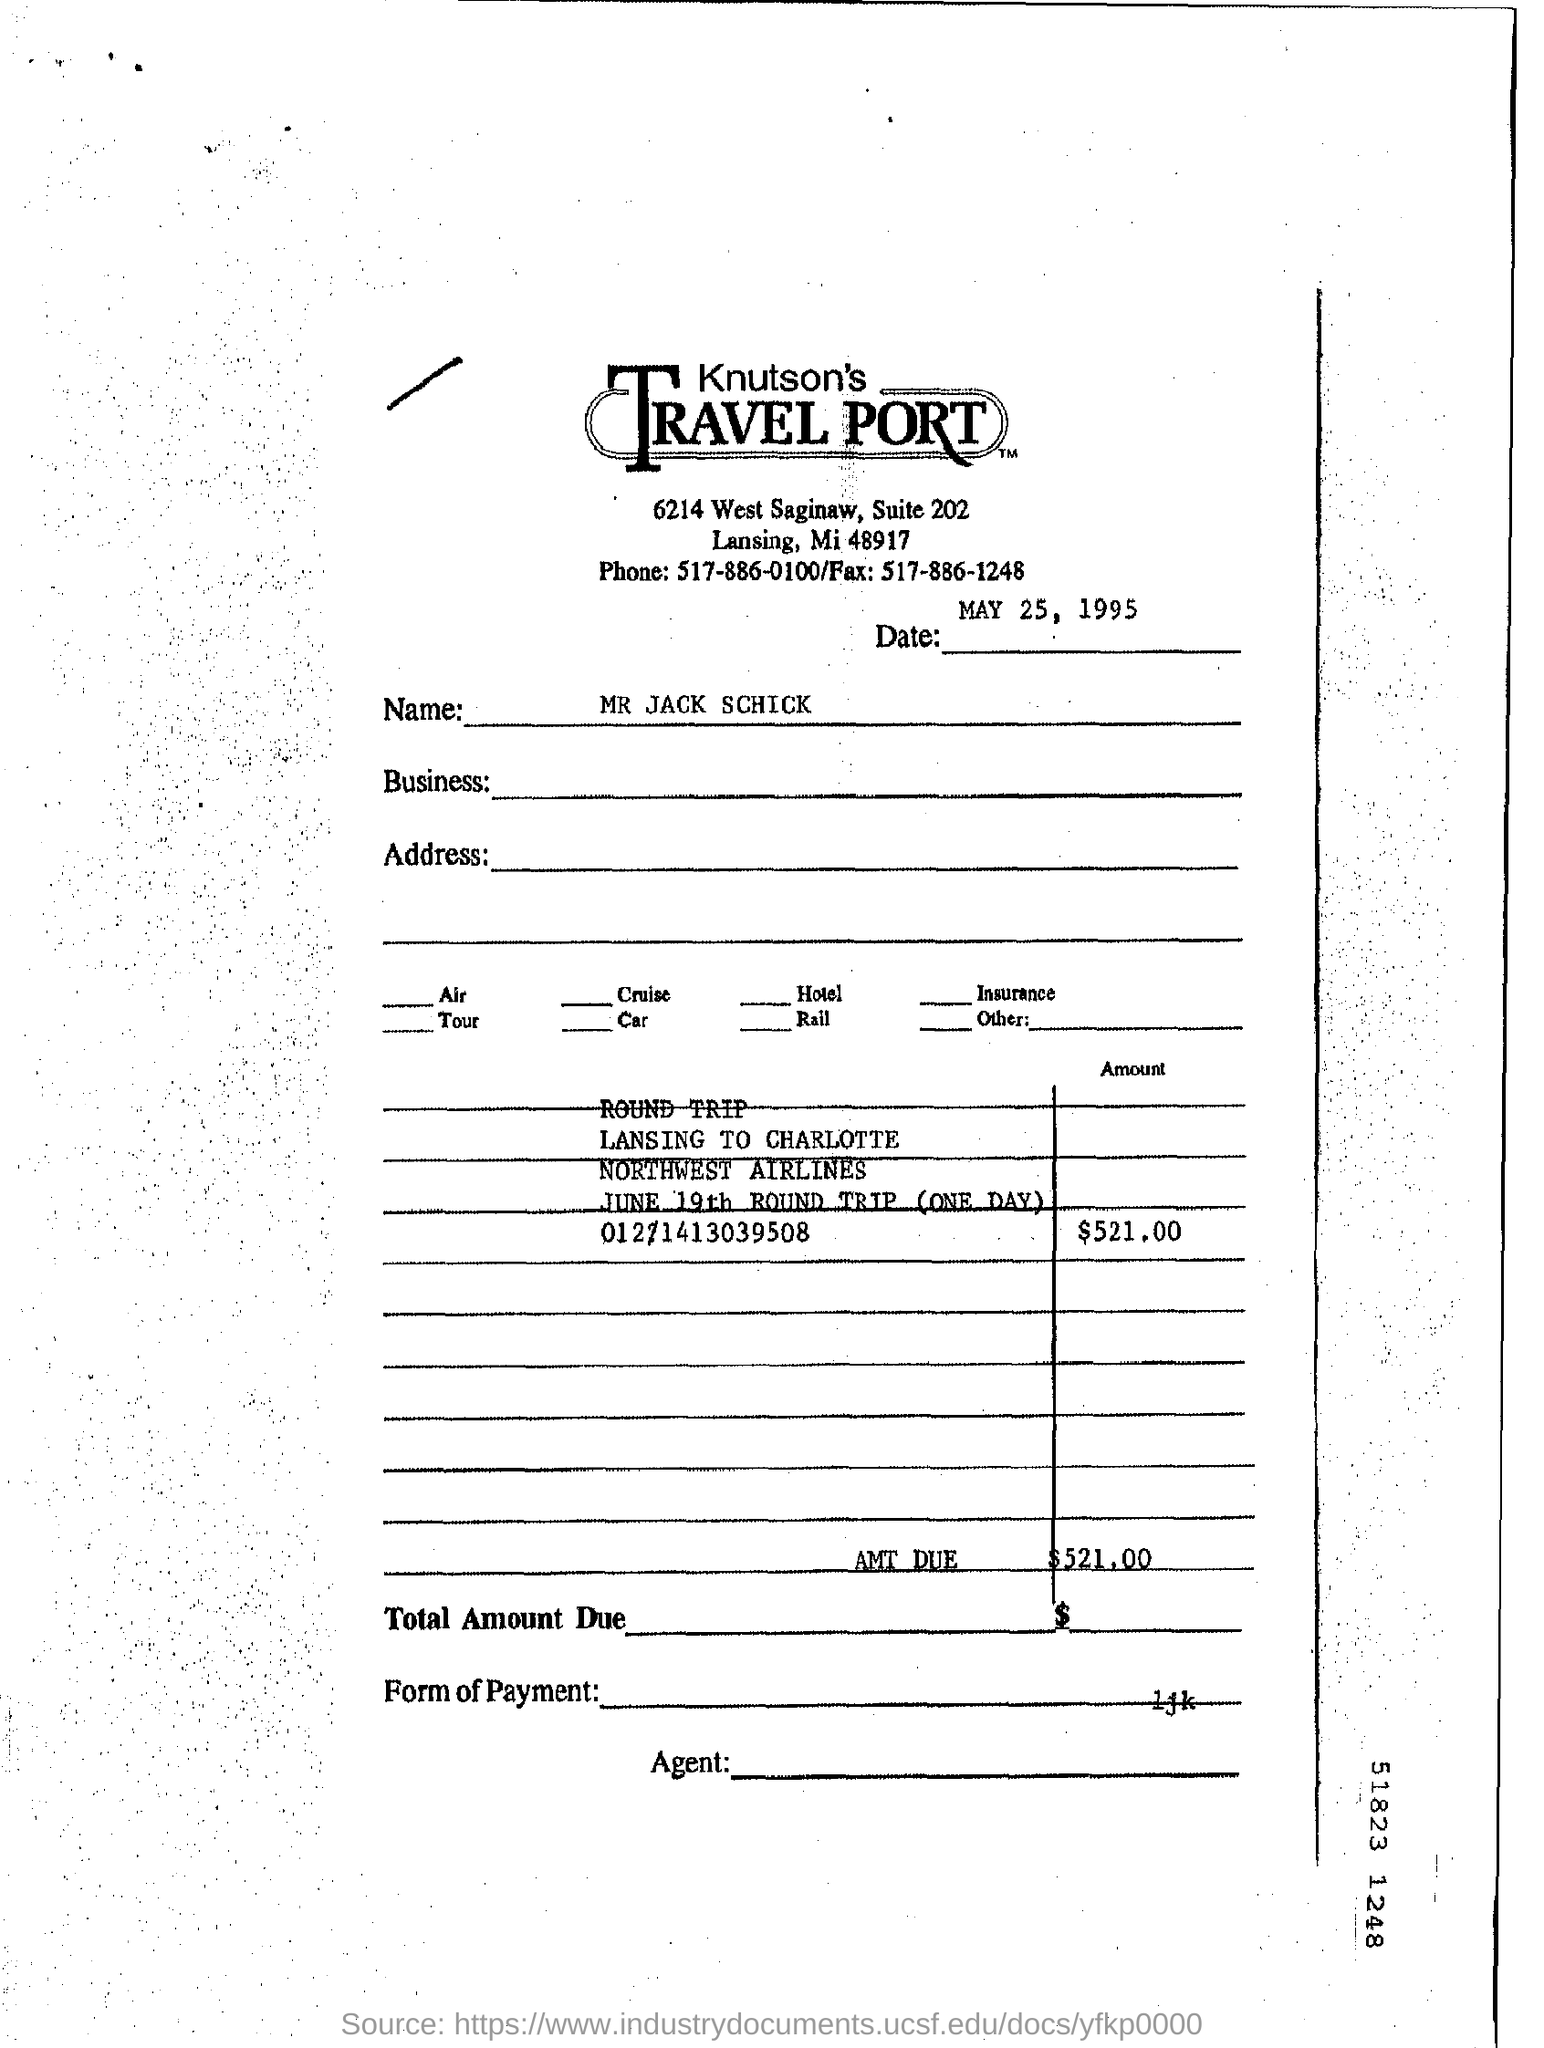Draw attention to some important aspects in this diagram. The suite number is 202. The fax number is 517-886-1248. The date mentioned at the top of the document is May 25, 1995. The name "MR JACK SCHICK" is written in the document. The phone number is 517-886-0100. 